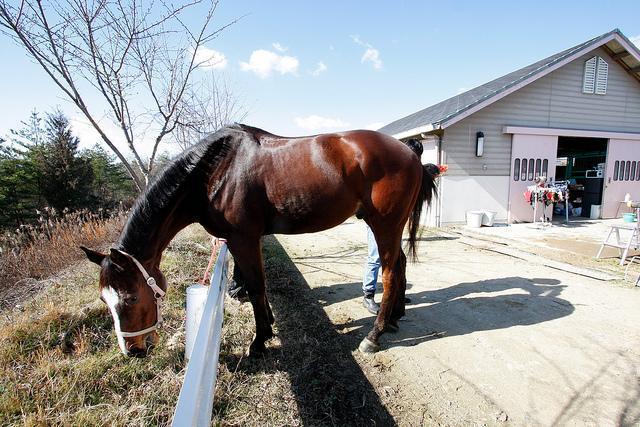How many horses can be seen?
Give a very brief answer. 1. 